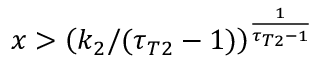<formula> <loc_0><loc_0><loc_500><loc_500>x > \left ( k _ { 2 } / ( \tau _ { T 2 } - 1 ) \right ) ^ { \frac { 1 } { \tau _ { T 2 } - 1 } }</formula> 